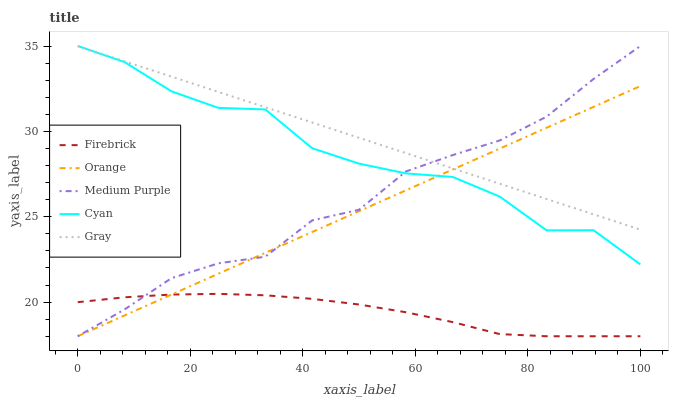Does Firebrick have the minimum area under the curve?
Answer yes or no. Yes. Does Gray have the maximum area under the curve?
Answer yes or no. Yes. Does Medium Purple have the minimum area under the curve?
Answer yes or no. No. Does Medium Purple have the maximum area under the curve?
Answer yes or no. No. Is Orange the smoothest?
Answer yes or no. Yes. Is Cyan the roughest?
Answer yes or no. Yes. Is Medium Purple the smoothest?
Answer yes or no. No. Is Medium Purple the roughest?
Answer yes or no. No. Does Orange have the lowest value?
Answer yes or no. Yes. Does Gray have the lowest value?
Answer yes or no. No. Does Cyan have the highest value?
Answer yes or no. Yes. Does Firebrick have the highest value?
Answer yes or no. No. Is Firebrick less than Gray?
Answer yes or no. Yes. Is Cyan greater than Firebrick?
Answer yes or no. Yes. Does Firebrick intersect Orange?
Answer yes or no. Yes. Is Firebrick less than Orange?
Answer yes or no. No. Is Firebrick greater than Orange?
Answer yes or no. No. Does Firebrick intersect Gray?
Answer yes or no. No. 